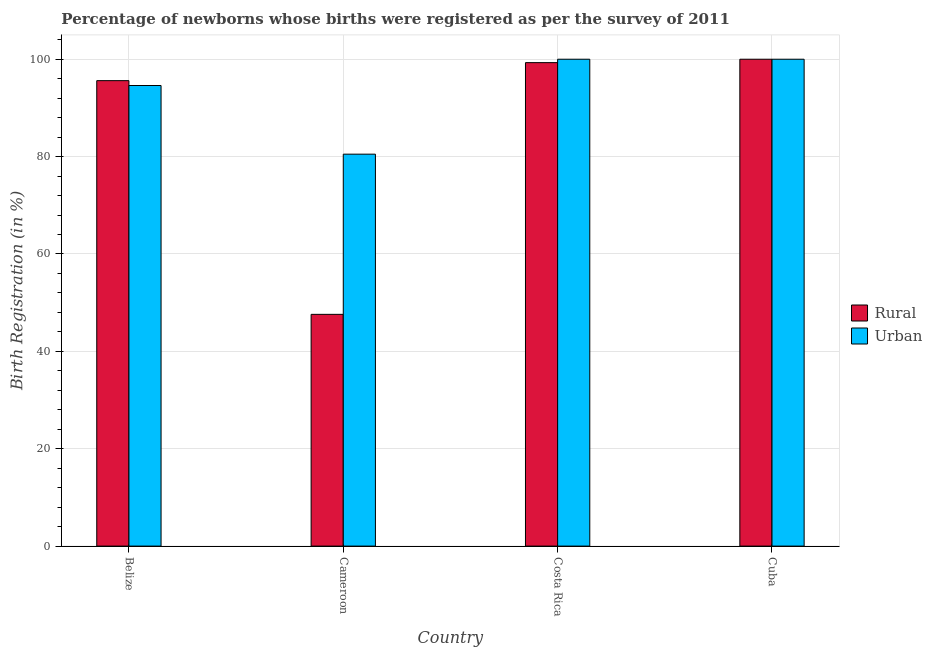How many groups of bars are there?
Your response must be concise. 4. Are the number of bars on each tick of the X-axis equal?
Offer a very short reply. Yes. How many bars are there on the 4th tick from the right?
Your answer should be very brief. 2. What is the label of the 2nd group of bars from the left?
Your answer should be very brief. Cameroon. What is the rural birth registration in Cameroon?
Your answer should be very brief. 47.6. Across all countries, what is the maximum urban birth registration?
Make the answer very short. 100. Across all countries, what is the minimum rural birth registration?
Offer a terse response. 47.6. In which country was the rural birth registration minimum?
Give a very brief answer. Cameroon. What is the total urban birth registration in the graph?
Ensure brevity in your answer.  375.1. What is the difference between the urban birth registration in Cameroon and that in Cuba?
Make the answer very short. -19.5. What is the difference between the urban birth registration in Costa Rica and the rural birth registration in Cameroon?
Ensure brevity in your answer.  52.4. What is the average urban birth registration per country?
Offer a very short reply. 93.78. What is the difference between the rural birth registration and urban birth registration in Cameroon?
Provide a succinct answer. -32.9. What is the ratio of the urban birth registration in Belize to that in Cameroon?
Ensure brevity in your answer.  1.18. Is the urban birth registration in Cameroon less than that in Costa Rica?
Provide a succinct answer. Yes. What is the difference between the highest and the second highest rural birth registration?
Your answer should be very brief. 0.7. What is the difference between the highest and the lowest urban birth registration?
Your response must be concise. 19.5. Is the sum of the rural birth registration in Belize and Cameroon greater than the maximum urban birth registration across all countries?
Make the answer very short. Yes. What does the 2nd bar from the left in Costa Rica represents?
Your response must be concise. Urban. What does the 1st bar from the right in Cameroon represents?
Ensure brevity in your answer.  Urban. How many countries are there in the graph?
Your answer should be very brief. 4. What is the difference between two consecutive major ticks on the Y-axis?
Provide a short and direct response. 20. Are the values on the major ticks of Y-axis written in scientific E-notation?
Offer a very short reply. No. Does the graph contain any zero values?
Your response must be concise. No. Does the graph contain grids?
Your answer should be compact. Yes. How many legend labels are there?
Ensure brevity in your answer.  2. How are the legend labels stacked?
Provide a short and direct response. Vertical. What is the title of the graph?
Make the answer very short. Percentage of newborns whose births were registered as per the survey of 2011. Does "Death rate" appear as one of the legend labels in the graph?
Keep it short and to the point. No. What is the label or title of the X-axis?
Keep it short and to the point. Country. What is the label or title of the Y-axis?
Your response must be concise. Birth Registration (in %). What is the Birth Registration (in %) of Rural in Belize?
Your answer should be compact. 95.6. What is the Birth Registration (in %) in Urban in Belize?
Make the answer very short. 94.6. What is the Birth Registration (in %) of Rural in Cameroon?
Offer a terse response. 47.6. What is the Birth Registration (in %) of Urban in Cameroon?
Provide a short and direct response. 80.5. What is the Birth Registration (in %) in Rural in Costa Rica?
Offer a very short reply. 99.3. What is the Birth Registration (in %) of Rural in Cuba?
Provide a succinct answer. 100. What is the Birth Registration (in %) of Urban in Cuba?
Your response must be concise. 100. Across all countries, what is the maximum Birth Registration (in %) of Rural?
Your response must be concise. 100. Across all countries, what is the minimum Birth Registration (in %) in Rural?
Make the answer very short. 47.6. Across all countries, what is the minimum Birth Registration (in %) of Urban?
Your answer should be very brief. 80.5. What is the total Birth Registration (in %) of Rural in the graph?
Offer a very short reply. 342.5. What is the total Birth Registration (in %) of Urban in the graph?
Make the answer very short. 375.1. What is the difference between the Birth Registration (in %) of Urban in Belize and that in Cameroon?
Your answer should be very brief. 14.1. What is the difference between the Birth Registration (in %) of Rural in Belize and that in Costa Rica?
Make the answer very short. -3.7. What is the difference between the Birth Registration (in %) of Rural in Belize and that in Cuba?
Make the answer very short. -4.4. What is the difference between the Birth Registration (in %) in Urban in Belize and that in Cuba?
Ensure brevity in your answer.  -5.4. What is the difference between the Birth Registration (in %) of Rural in Cameroon and that in Costa Rica?
Your answer should be compact. -51.7. What is the difference between the Birth Registration (in %) in Urban in Cameroon and that in Costa Rica?
Provide a succinct answer. -19.5. What is the difference between the Birth Registration (in %) in Rural in Cameroon and that in Cuba?
Your answer should be compact. -52.4. What is the difference between the Birth Registration (in %) of Urban in Cameroon and that in Cuba?
Keep it short and to the point. -19.5. What is the difference between the Birth Registration (in %) of Rural in Costa Rica and that in Cuba?
Provide a short and direct response. -0.7. What is the difference between the Birth Registration (in %) in Rural in Belize and the Birth Registration (in %) in Urban in Cameroon?
Offer a terse response. 15.1. What is the difference between the Birth Registration (in %) in Rural in Belize and the Birth Registration (in %) in Urban in Cuba?
Provide a succinct answer. -4.4. What is the difference between the Birth Registration (in %) in Rural in Cameroon and the Birth Registration (in %) in Urban in Costa Rica?
Offer a very short reply. -52.4. What is the difference between the Birth Registration (in %) of Rural in Cameroon and the Birth Registration (in %) of Urban in Cuba?
Your answer should be compact. -52.4. What is the average Birth Registration (in %) in Rural per country?
Ensure brevity in your answer.  85.62. What is the average Birth Registration (in %) of Urban per country?
Provide a short and direct response. 93.78. What is the difference between the Birth Registration (in %) in Rural and Birth Registration (in %) in Urban in Cameroon?
Give a very brief answer. -32.9. What is the difference between the Birth Registration (in %) in Rural and Birth Registration (in %) in Urban in Costa Rica?
Your answer should be compact. -0.7. What is the ratio of the Birth Registration (in %) of Rural in Belize to that in Cameroon?
Provide a short and direct response. 2.01. What is the ratio of the Birth Registration (in %) of Urban in Belize to that in Cameroon?
Your answer should be very brief. 1.18. What is the ratio of the Birth Registration (in %) in Rural in Belize to that in Costa Rica?
Your answer should be compact. 0.96. What is the ratio of the Birth Registration (in %) of Urban in Belize to that in Costa Rica?
Your response must be concise. 0.95. What is the ratio of the Birth Registration (in %) of Rural in Belize to that in Cuba?
Your answer should be very brief. 0.96. What is the ratio of the Birth Registration (in %) of Urban in Belize to that in Cuba?
Your answer should be very brief. 0.95. What is the ratio of the Birth Registration (in %) of Rural in Cameroon to that in Costa Rica?
Make the answer very short. 0.48. What is the ratio of the Birth Registration (in %) of Urban in Cameroon to that in Costa Rica?
Ensure brevity in your answer.  0.81. What is the ratio of the Birth Registration (in %) in Rural in Cameroon to that in Cuba?
Make the answer very short. 0.48. What is the ratio of the Birth Registration (in %) of Urban in Cameroon to that in Cuba?
Your response must be concise. 0.81. What is the ratio of the Birth Registration (in %) in Rural in Costa Rica to that in Cuba?
Your answer should be very brief. 0.99. What is the ratio of the Birth Registration (in %) of Urban in Costa Rica to that in Cuba?
Make the answer very short. 1. What is the difference between the highest and the second highest Birth Registration (in %) in Urban?
Provide a short and direct response. 0. What is the difference between the highest and the lowest Birth Registration (in %) of Rural?
Give a very brief answer. 52.4. What is the difference between the highest and the lowest Birth Registration (in %) of Urban?
Offer a terse response. 19.5. 